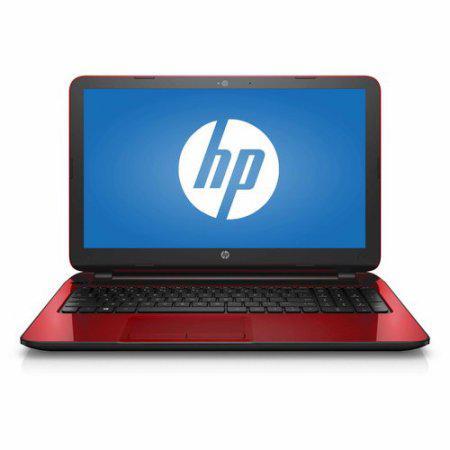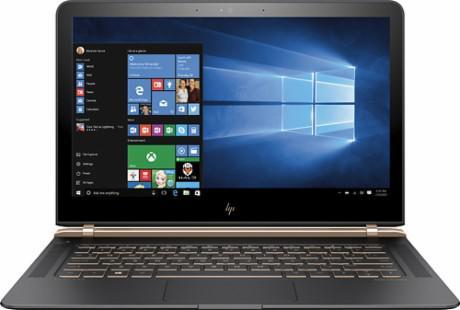The first image is the image on the left, the second image is the image on the right. Examine the images to the left and right. Is the description "the laptop on the right image has a black background" accurate? Answer yes or no. No. 